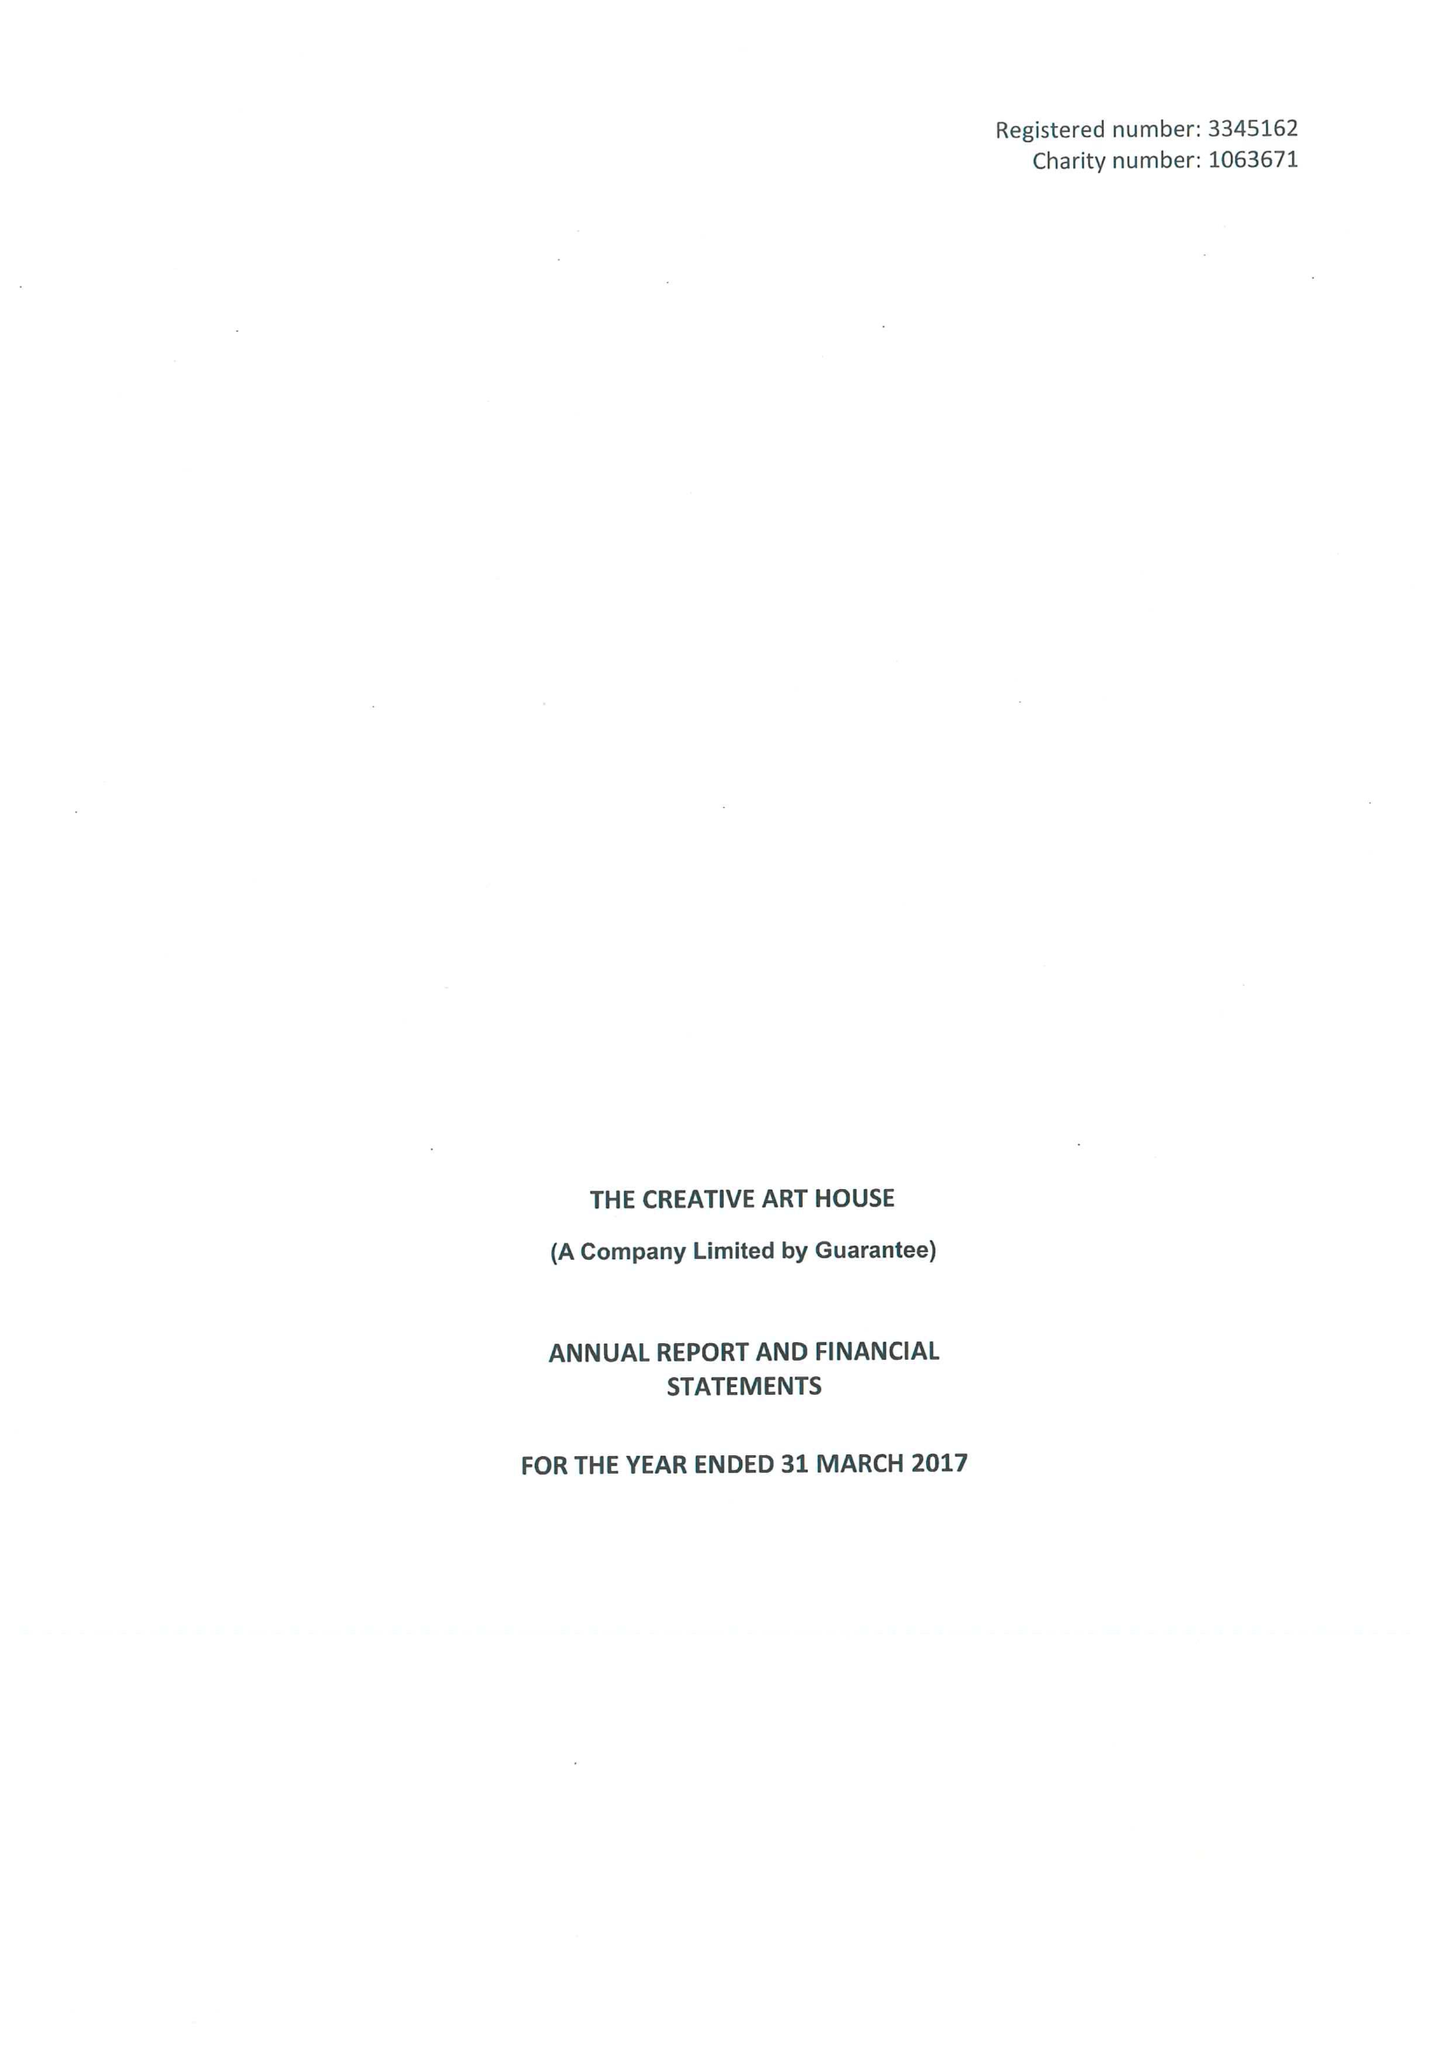What is the value for the charity_name?
Answer the question using a single word or phrase. The Creative Art House 